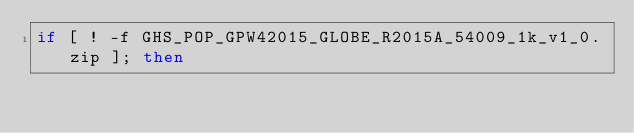<code> <loc_0><loc_0><loc_500><loc_500><_Bash_>if [ ! -f GHS_POP_GPW42015_GLOBE_R2015A_54009_1k_v1_0.zip ]; then</code> 